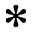<formula> <loc_0><loc_0><loc_500><loc_500>*</formula> 